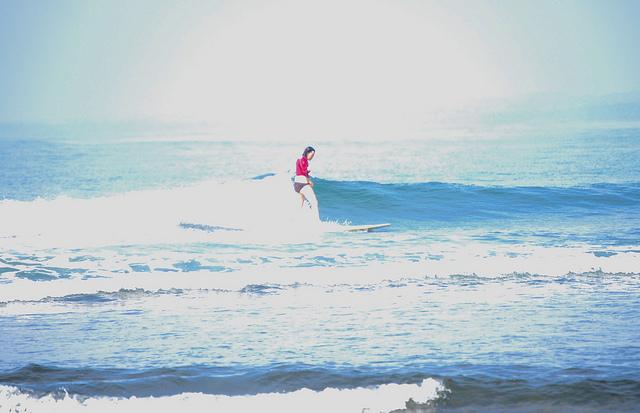How many people are in the water?
Be succinct. 1. Is the water calm?
Short answer required. No. What color is the water?
Answer briefly. Blue. Is the weather good for the activity shown?
Answer briefly. Yes. Is the image blown out?
Answer briefly. Yes. 